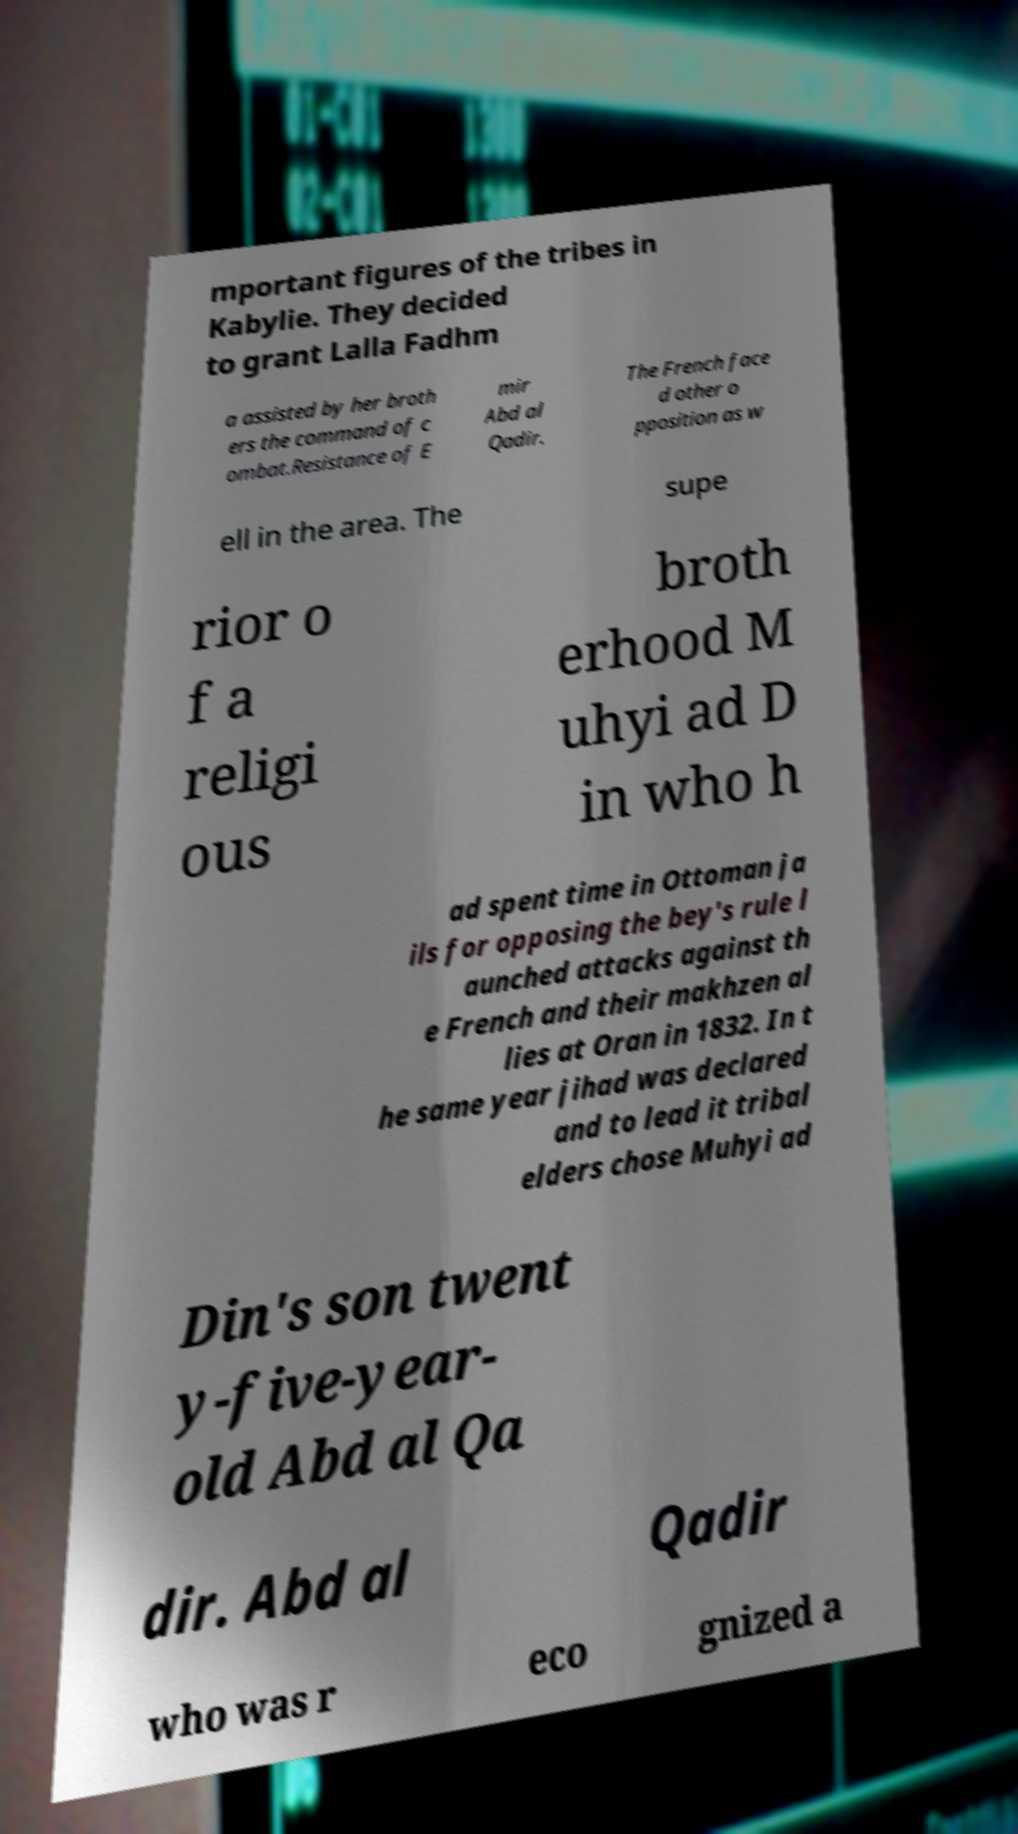Could you extract and type out the text from this image? mportant figures of the tribes in Kabylie. They decided to grant Lalla Fadhm a assisted by her broth ers the command of c ombat.Resistance of E mir Abd al Qadir. The French face d other o pposition as w ell in the area. The supe rior o f a religi ous broth erhood M uhyi ad D in who h ad spent time in Ottoman ja ils for opposing the bey's rule l aunched attacks against th e French and their makhzen al lies at Oran in 1832. In t he same year jihad was declared and to lead it tribal elders chose Muhyi ad Din's son twent y-five-year- old Abd al Qa dir. Abd al Qadir who was r eco gnized a 